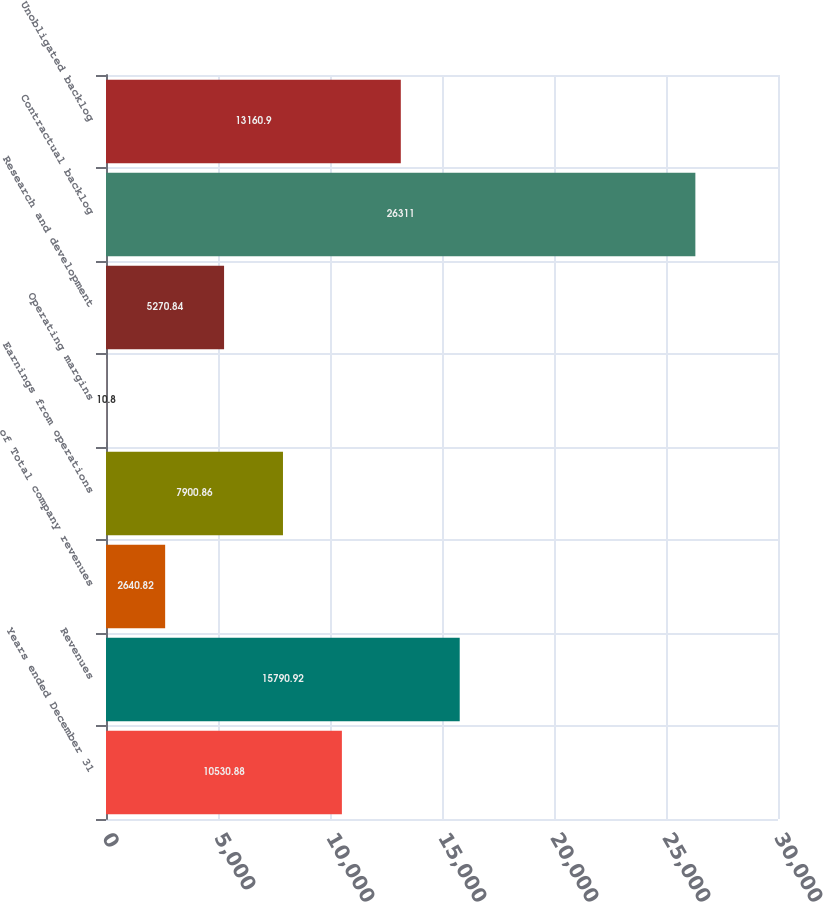Convert chart to OTSL. <chart><loc_0><loc_0><loc_500><loc_500><bar_chart><fcel>Years ended December 31<fcel>Revenues<fcel>of Total company revenues<fcel>Earnings from operations<fcel>Operating margins<fcel>Research and development<fcel>Contractual backlog<fcel>Unobligated backlog<nl><fcel>10530.9<fcel>15790.9<fcel>2640.82<fcel>7900.86<fcel>10.8<fcel>5270.84<fcel>26311<fcel>13160.9<nl></chart> 